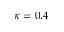<formula> <loc_0><loc_0><loc_500><loc_500>\kappa = 0 . 4</formula> 